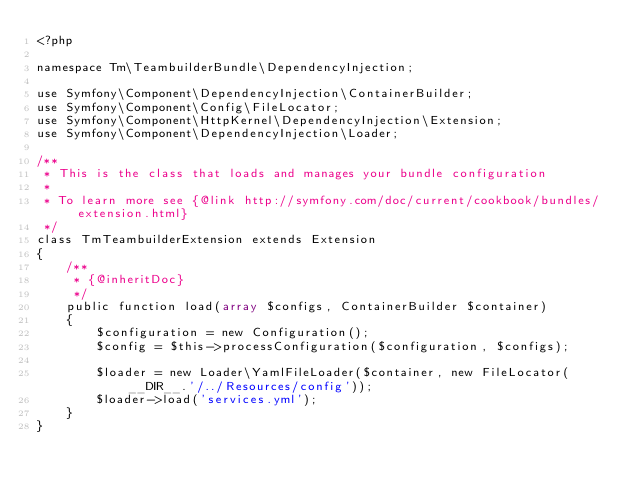<code> <loc_0><loc_0><loc_500><loc_500><_PHP_><?php

namespace Tm\TeambuilderBundle\DependencyInjection;

use Symfony\Component\DependencyInjection\ContainerBuilder;
use Symfony\Component\Config\FileLocator;
use Symfony\Component\HttpKernel\DependencyInjection\Extension;
use Symfony\Component\DependencyInjection\Loader;

/**
 * This is the class that loads and manages your bundle configuration
 *
 * To learn more see {@link http://symfony.com/doc/current/cookbook/bundles/extension.html}
 */
class TmTeambuilderExtension extends Extension
{
    /**
     * {@inheritDoc}
     */
    public function load(array $configs, ContainerBuilder $container)
    {
        $configuration = new Configuration();
        $config = $this->processConfiguration($configuration, $configs);

        $loader = new Loader\YamlFileLoader($container, new FileLocator(__DIR__.'/../Resources/config'));
        $loader->load('services.yml');
    }
}
</code> 